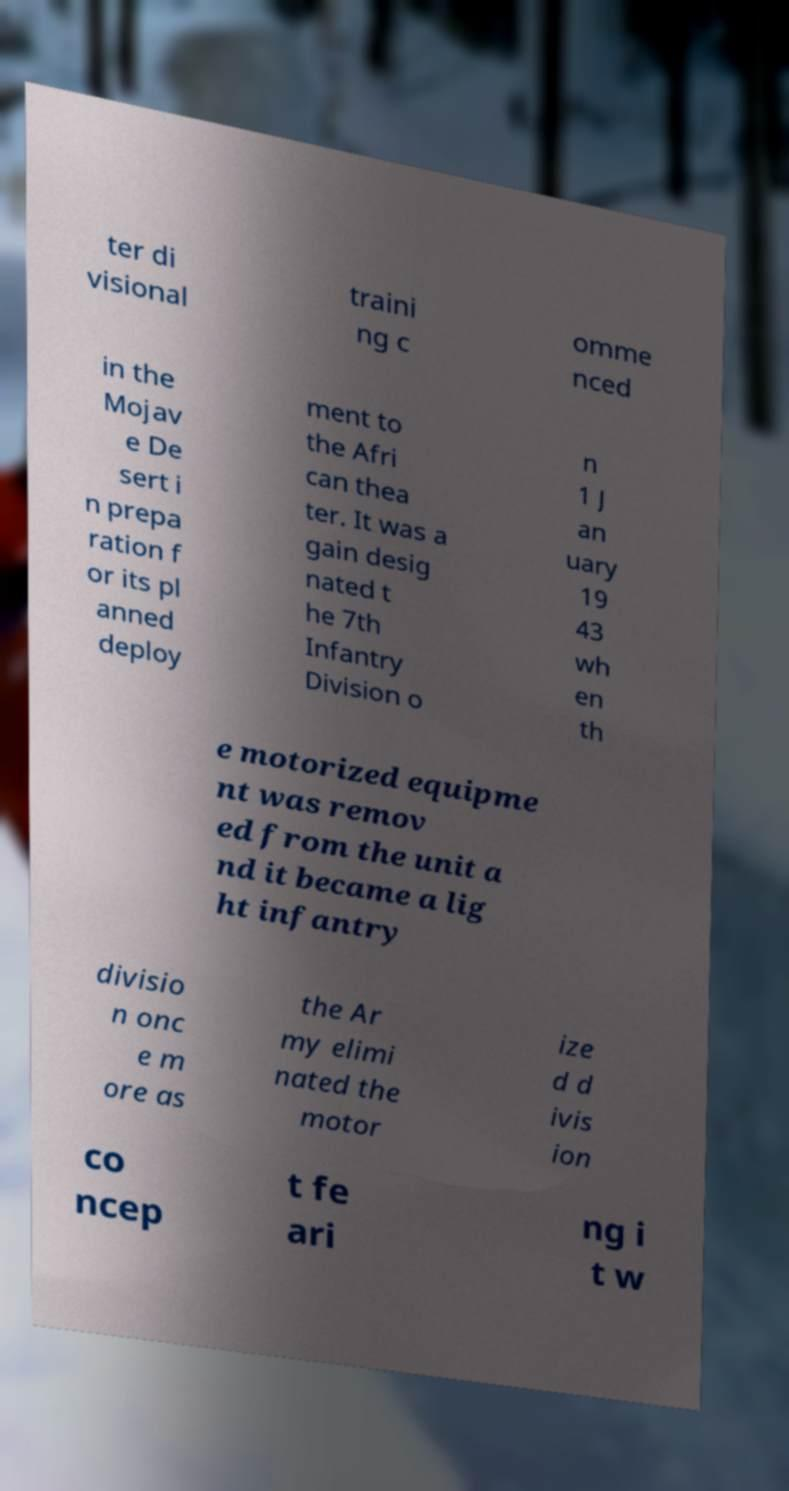What messages or text are displayed in this image? I need them in a readable, typed format. ter di visional traini ng c omme nced in the Mojav e De sert i n prepa ration f or its pl anned deploy ment to the Afri can thea ter. It was a gain desig nated t he 7th Infantry Division o n 1 J an uary 19 43 wh en th e motorized equipme nt was remov ed from the unit a nd it became a lig ht infantry divisio n onc e m ore as the Ar my elimi nated the motor ize d d ivis ion co ncep t fe ari ng i t w 